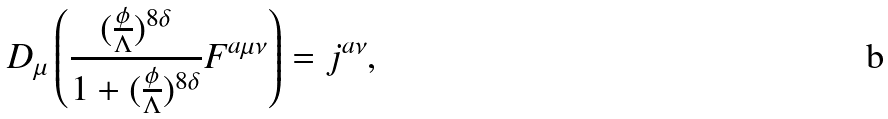Convert formula to latex. <formula><loc_0><loc_0><loc_500><loc_500>D _ { \mu } \left ( \frac { ( \frac { \phi } { \Lambda } ) ^ { 8 \delta } } { 1 + ( \frac { \phi } { \Lambda } ) ^ { 8 \delta } } F ^ { a \mu \nu } \right ) = j ^ { a \nu } ,</formula> 